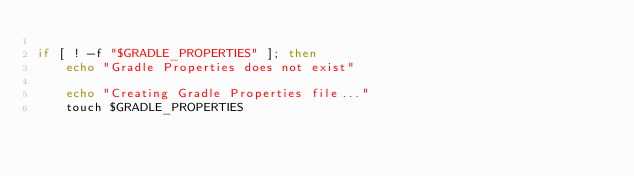<code> <loc_0><loc_0><loc_500><loc_500><_Bash_>
if [ ! -f "$GRADLE_PROPERTIES" ]; then
    echo "Gradle Properties does not exist"

    echo "Creating Gradle Properties file..."
    touch $GRADLE_PROPERTIES
</code> 